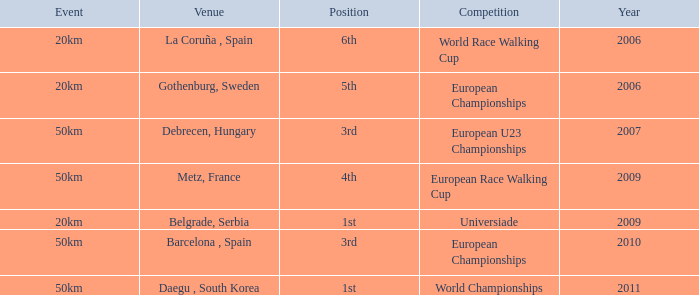Could you parse the entire table as a dict? {'header': ['Event', 'Venue', 'Position', 'Competition', 'Year'], 'rows': [['20km', 'La Coruña , Spain', '6th', 'World Race Walking Cup', '2006'], ['20km', 'Gothenburg, Sweden', '5th', 'European Championships', '2006'], ['50km', 'Debrecen, Hungary', '3rd', 'European U23 Championships', '2007'], ['50km', 'Metz, France', '4th', 'European Race Walking Cup', '2009'], ['20km', 'Belgrade, Serbia', '1st', 'Universiade', '2009'], ['50km', 'Barcelona , Spain', '3rd', 'European Championships', '2010'], ['50km', 'Daegu , South Korea', '1st', 'World Championships', '2011']]} Which Competition has an Event of 50km, a Year earlier than 2010 and a Position of 3rd? European U23 Championships. 